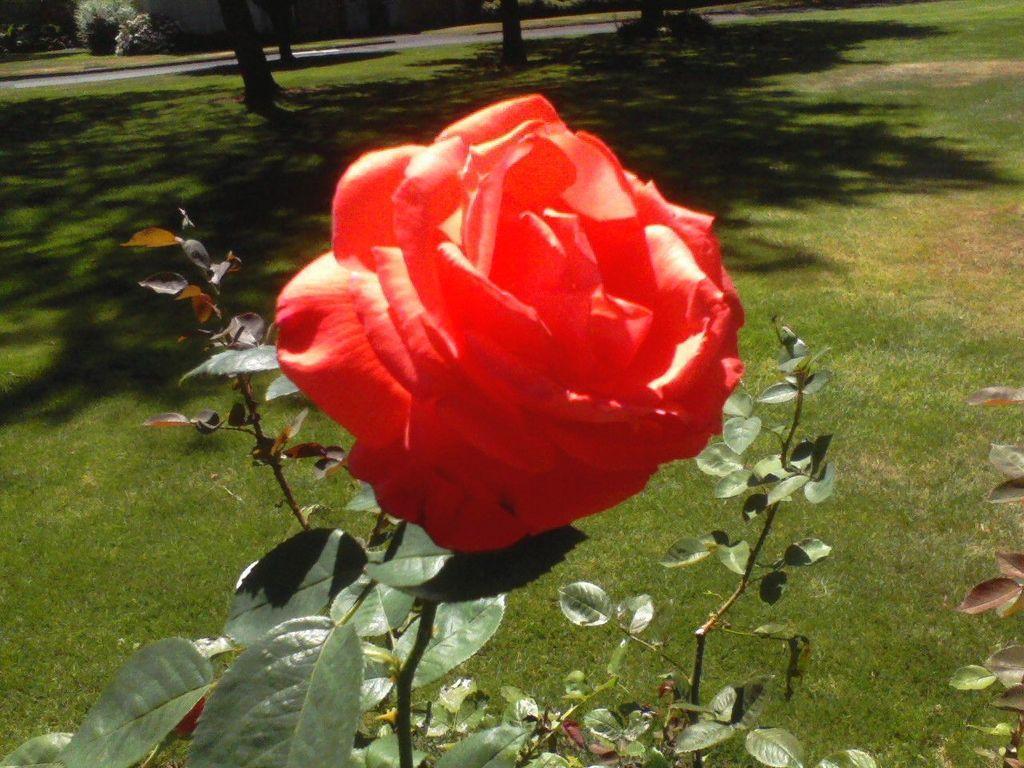In one or two sentences, can you explain what this image depicts? In the foreground of the picture we can see leaves, stems, rose flower and grass. In the background there are trees, plants, grass and other objects. 